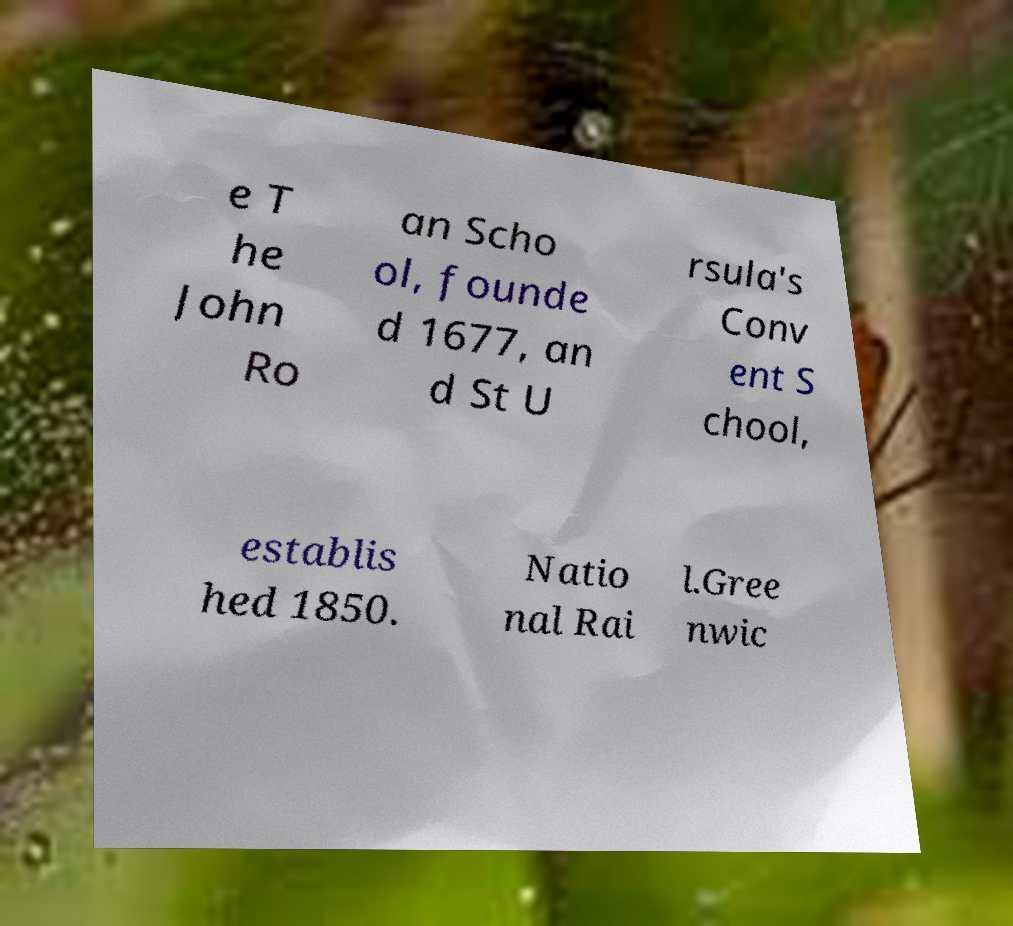Could you extract and type out the text from this image? e T he John Ro an Scho ol, founde d 1677, an d St U rsula's Conv ent S chool, establis hed 1850. Natio nal Rai l.Gree nwic 